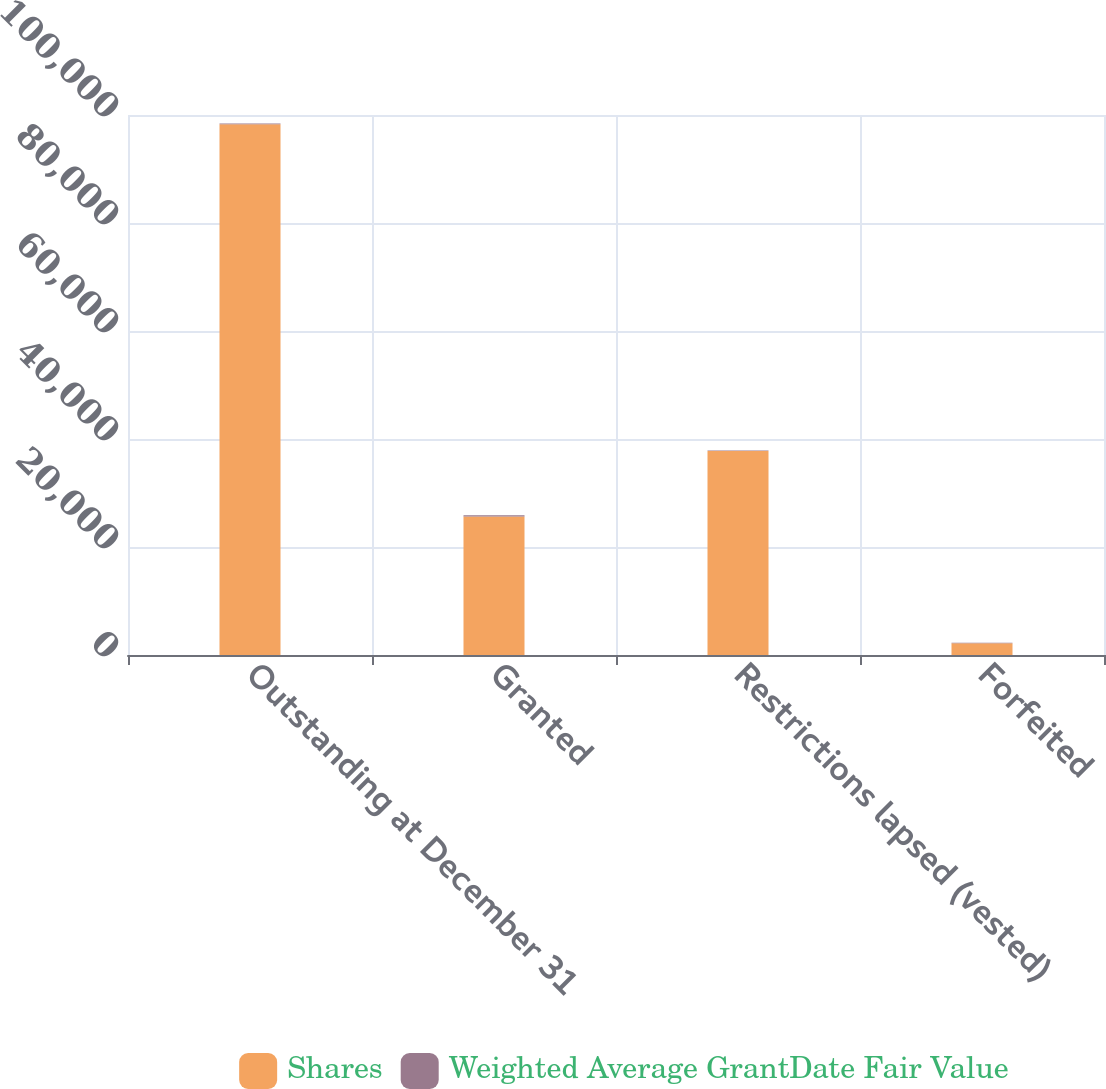<chart> <loc_0><loc_0><loc_500><loc_500><stacked_bar_chart><ecel><fcel>Outstanding at December 31<fcel>Granted<fcel>Restrictions lapsed (vested)<fcel>Forfeited<nl><fcel>Shares<fcel>98284<fcel>25662<fcel>37779<fcel>2170<nl><fcel>Weighted Average GrantDate Fair Value<fcel>129.05<fcel>201.22<fcel>95.35<fcel>105.53<nl></chart> 